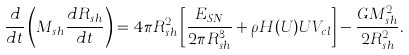<formula> <loc_0><loc_0><loc_500><loc_500>\frac { d } { d t } \left ( M _ { s h } \frac { d R _ { s h } } { d t } \right ) = 4 \pi R _ { s h } ^ { 2 } \left [ \frac { E _ { S N } } { 2 \pi R _ { s h } ^ { 3 } } + \rho H ( U ) U V _ { c l } \right ] - \frac { G M _ { s h } ^ { 2 } } { 2 R _ { s h } ^ { 2 } } .</formula> 